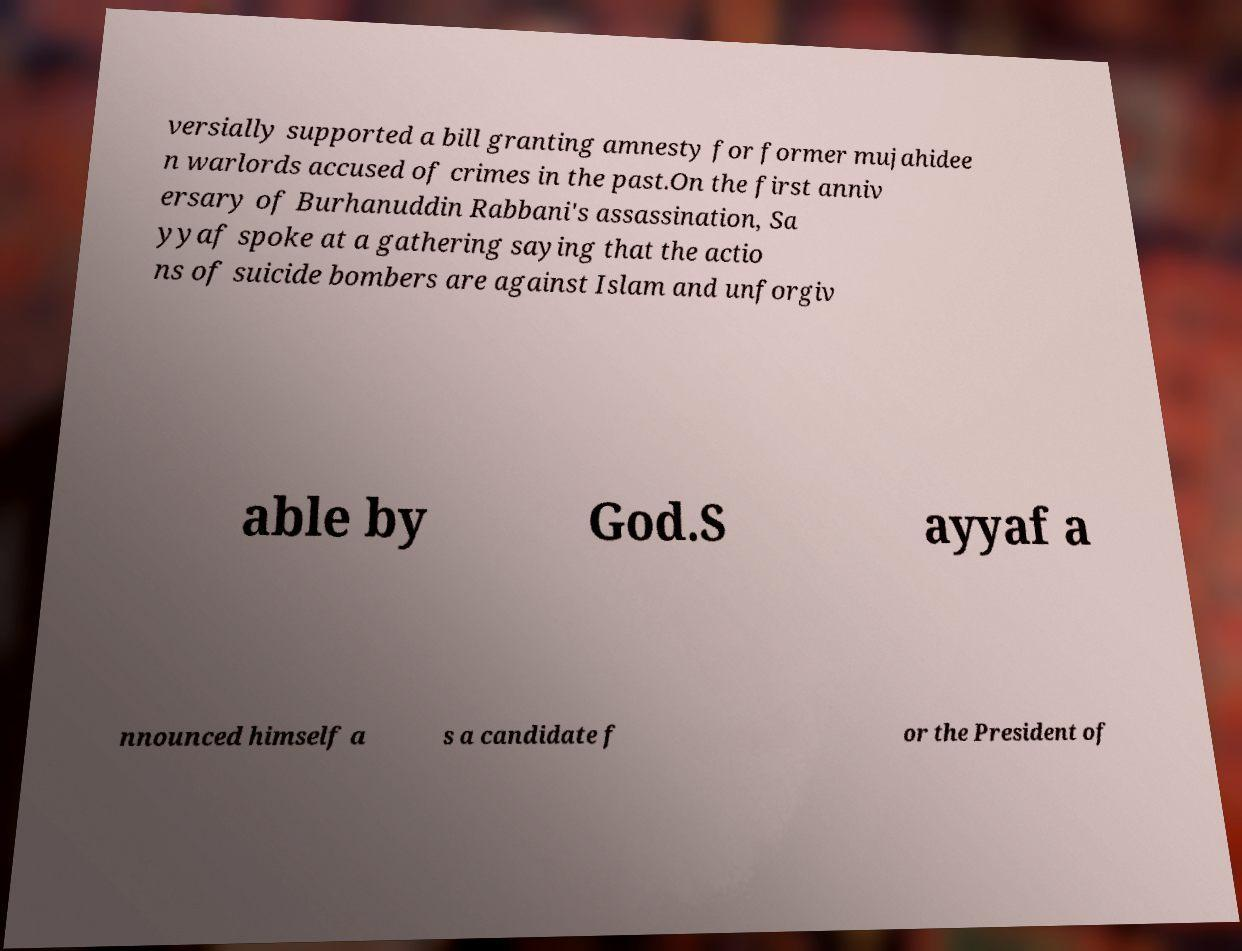There's text embedded in this image that I need extracted. Can you transcribe it verbatim? versially supported a bill granting amnesty for former mujahidee n warlords accused of crimes in the past.On the first anniv ersary of Burhanuddin Rabbani's assassination, Sa yyaf spoke at a gathering saying that the actio ns of suicide bombers are against Islam and unforgiv able by God.S ayyaf a nnounced himself a s a candidate f or the President of 